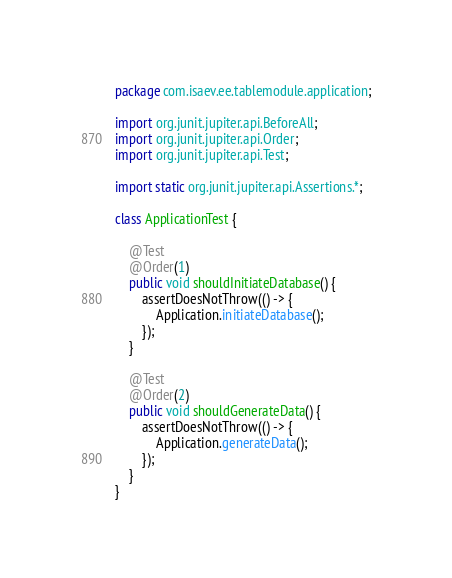Convert code to text. <code><loc_0><loc_0><loc_500><loc_500><_Java_>package com.isaev.ee.tablemodule.application;

import org.junit.jupiter.api.BeforeAll;
import org.junit.jupiter.api.Order;
import org.junit.jupiter.api.Test;

import static org.junit.jupiter.api.Assertions.*;

class ApplicationTest {

    @Test
    @Order(1)
    public void shouldInitiateDatabase() {
        assertDoesNotThrow(() -> {
            Application.initiateDatabase();
        });
    }

    @Test
    @Order(2)
    public void shouldGenerateData() {
        assertDoesNotThrow(() -> {
            Application.generateData();
        });
    }
}</code> 